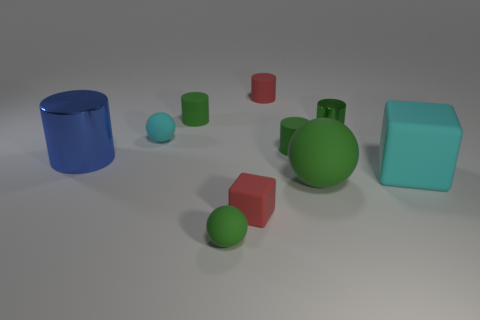Which objects in the image are cylinders? Within the image, the blue object on the left is a cylinder. It's standing upright and its circular top is visible from this perspective. 